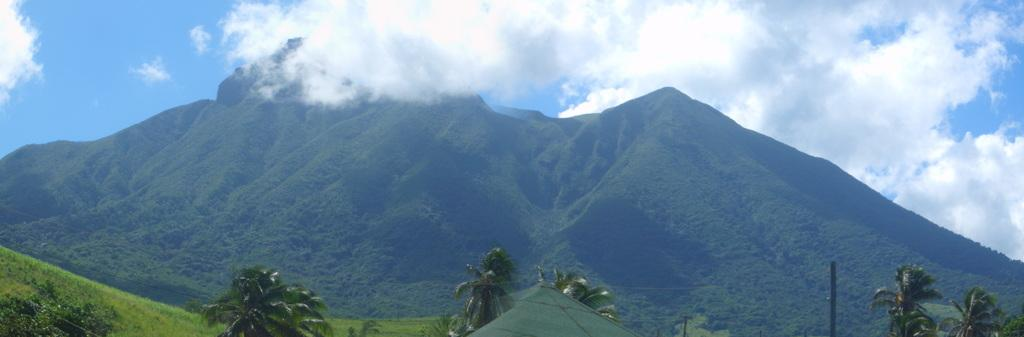What type of vegetation or plants can be seen in the image? There is greenery in the image, which suggests the presence of plants or vegetation. What is visible at the top of the image? The sky is visible at the top of the image. What type of juice is being poured from a finger in the image? There is no juice or finger present in the image. What is causing the greenery to laugh in the image? The greenery does not have the ability to laugh, as it is a non-living object. 